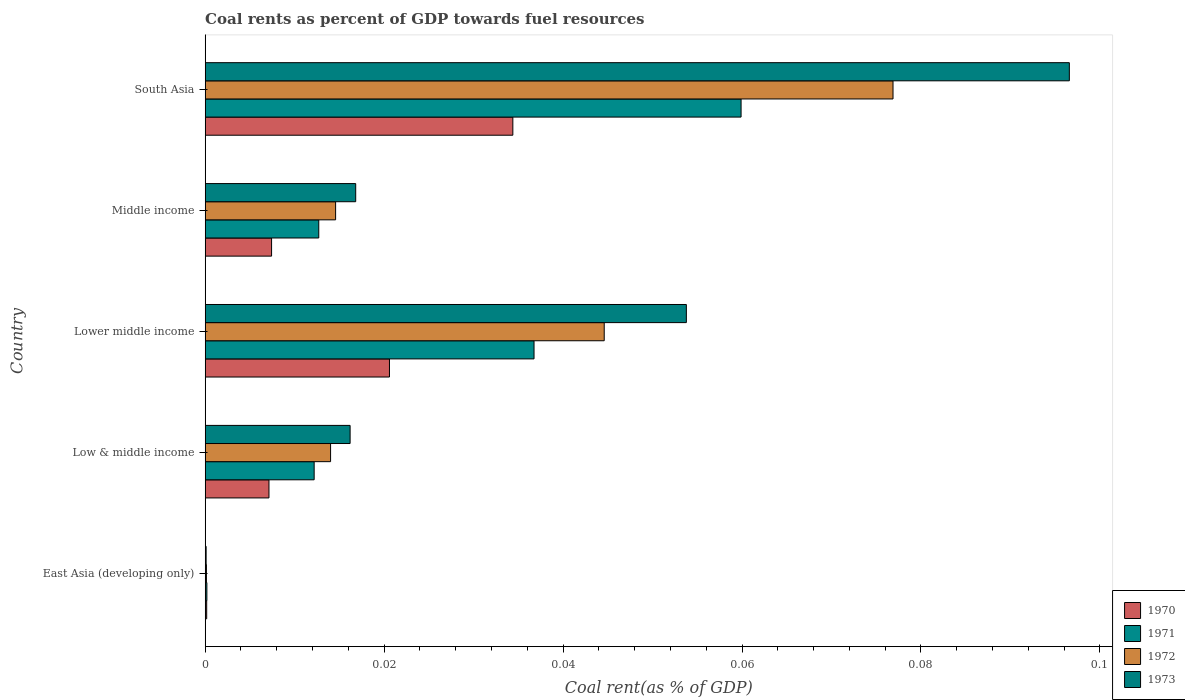Are the number of bars on each tick of the Y-axis equal?
Keep it short and to the point. Yes. How many bars are there on the 2nd tick from the top?
Offer a very short reply. 4. How many bars are there on the 3rd tick from the bottom?
Give a very brief answer. 4. What is the coal rent in 1973 in East Asia (developing only)?
Your response must be concise. 0. Across all countries, what is the maximum coal rent in 1970?
Offer a terse response. 0.03. Across all countries, what is the minimum coal rent in 1972?
Make the answer very short. 0. In which country was the coal rent in 1971 maximum?
Your answer should be compact. South Asia. In which country was the coal rent in 1972 minimum?
Keep it short and to the point. East Asia (developing only). What is the total coal rent in 1970 in the graph?
Keep it short and to the point. 0.07. What is the difference between the coal rent in 1970 in East Asia (developing only) and that in Middle income?
Your response must be concise. -0.01. What is the difference between the coal rent in 1973 in South Asia and the coal rent in 1971 in East Asia (developing only)?
Ensure brevity in your answer.  0.1. What is the average coal rent in 1971 per country?
Provide a succinct answer. 0.02. What is the difference between the coal rent in 1973 and coal rent in 1972 in Lower middle income?
Provide a succinct answer. 0.01. In how many countries, is the coal rent in 1972 greater than 0.052000000000000005 %?
Offer a terse response. 1. What is the ratio of the coal rent in 1970 in East Asia (developing only) to that in Low & middle income?
Offer a very short reply. 0.02. Is the coal rent in 1973 in East Asia (developing only) less than that in Low & middle income?
Your response must be concise. Yes. Is the difference between the coal rent in 1973 in Low & middle income and Middle income greater than the difference between the coal rent in 1972 in Low & middle income and Middle income?
Your answer should be compact. No. What is the difference between the highest and the second highest coal rent in 1970?
Provide a succinct answer. 0.01. What is the difference between the highest and the lowest coal rent in 1973?
Keep it short and to the point. 0.1. Is it the case that in every country, the sum of the coal rent in 1970 and coal rent in 1973 is greater than the sum of coal rent in 1972 and coal rent in 1971?
Your answer should be compact. No. Is it the case that in every country, the sum of the coal rent in 1973 and coal rent in 1971 is greater than the coal rent in 1972?
Your answer should be compact. Yes. How many bars are there?
Your answer should be very brief. 20. Does the graph contain any zero values?
Provide a succinct answer. No. Does the graph contain grids?
Ensure brevity in your answer.  No. How many legend labels are there?
Your response must be concise. 4. How are the legend labels stacked?
Offer a very short reply. Vertical. What is the title of the graph?
Provide a short and direct response. Coal rents as percent of GDP towards fuel resources. Does "1985" appear as one of the legend labels in the graph?
Ensure brevity in your answer.  No. What is the label or title of the X-axis?
Give a very brief answer. Coal rent(as % of GDP). What is the Coal rent(as % of GDP) in 1970 in East Asia (developing only)?
Provide a short and direct response. 0. What is the Coal rent(as % of GDP) of 1971 in East Asia (developing only)?
Make the answer very short. 0. What is the Coal rent(as % of GDP) in 1972 in East Asia (developing only)?
Your answer should be compact. 0. What is the Coal rent(as % of GDP) in 1973 in East Asia (developing only)?
Your answer should be very brief. 0. What is the Coal rent(as % of GDP) in 1970 in Low & middle income?
Offer a very short reply. 0.01. What is the Coal rent(as % of GDP) in 1971 in Low & middle income?
Ensure brevity in your answer.  0.01. What is the Coal rent(as % of GDP) of 1972 in Low & middle income?
Your response must be concise. 0.01. What is the Coal rent(as % of GDP) of 1973 in Low & middle income?
Offer a terse response. 0.02. What is the Coal rent(as % of GDP) in 1970 in Lower middle income?
Your response must be concise. 0.02. What is the Coal rent(as % of GDP) of 1971 in Lower middle income?
Provide a short and direct response. 0.04. What is the Coal rent(as % of GDP) of 1972 in Lower middle income?
Offer a very short reply. 0.04. What is the Coal rent(as % of GDP) in 1973 in Lower middle income?
Give a very brief answer. 0.05. What is the Coal rent(as % of GDP) in 1970 in Middle income?
Offer a terse response. 0.01. What is the Coal rent(as % of GDP) in 1971 in Middle income?
Provide a succinct answer. 0.01. What is the Coal rent(as % of GDP) of 1972 in Middle income?
Provide a short and direct response. 0.01. What is the Coal rent(as % of GDP) in 1973 in Middle income?
Your response must be concise. 0.02. What is the Coal rent(as % of GDP) of 1970 in South Asia?
Your response must be concise. 0.03. What is the Coal rent(as % of GDP) in 1971 in South Asia?
Your answer should be very brief. 0.06. What is the Coal rent(as % of GDP) of 1972 in South Asia?
Offer a very short reply. 0.08. What is the Coal rent(as % of GDP) of 1973 in South Asia?
Offer a very short reply. 0.1. Across all countries, what is the maximum Coal rent(as % of GDP) of 1970?
Keep it short and to the point. 0.03. Across all countries, what is the maximum Coal rent(as % of GDP) of 1971?
Your response must be concise. 0.06. Across all countries, what is the maximum Coal rent(as % of GDP) of 1972?
Your answer should be very brief. 0.08. Across all countries, what is the maximum Coal rent(as % of GDP) in 1973?
Make the answer very short. 0.1. Across all countries, what is the minimum Coal rent(as % of GDP) in 1970?
Give a very brief answer. 0. Across all countries, what is the minimum Coal rent(as % of GDP) of 1971?
Keep it short and to the point. 0. Across all countries, what is the minimum Coal rent(as % of GDP) in 1972?
Give a very brief answer. 0. Across all countries, what is the minimum Coal rent(as % of GDP) in 1973?
Your response must be concise. 0. What is the total Coal rent(as % of GDP) in 1970 in the graph?
Your answer should be compact. 0.07. What is the total Coal rent(as % of GDP) of 1971 in the graph?
Provide a succinct answer. 0.12. What is the total Coal rent(as % of GDP) of 1972 in the graph?
Make the answer very short. 0.15. What is the total Coal rent(as % of GDP) of 1973 in the graph?
Your answer should be compact. 0.18. What is the difference between the Coal rent(as % of GDP) of 1970 in East Asia (developing only) and that in Low & middle income?
Give a very brief answer. -0.01. What is the difference between the Coal rent(as % of GDP) in 1971 in East Asia (developing only) and that in Low & middle income?
Offer a terse response. -0.01. What is the difference between the Coal rent(as % of GDP) of 1972 in East Asia (developing only) and that in Low & middle income?
Offer a terse response. -0.01. What is the difference between the Coal rent(as % of GDP) of 1973 in East Asia (developing only) and that in Low & middle income?
Provide a succinct answer. -0.02. What is the difference between the Coal rent(as % of GDP) of 1970 in East Asia (developing only) and that in Lower middle income?
Provide a short and direct response. -0.02. What is the difference between the Coal rent(as % of GDP) of 1971 in East Asia (developing only) and that in Lower middle income?
Offer a terse response. -0.04. What is the difference between the Coal rent(as % of GDP) of 1972 in East Asia (developing only) and that in Lower middle income?
Your answer should be compact. -0.04. What is the difference between the Coal rent(as % of GDP) of 1973 in East Asia (developing only) and that in Lower middle income?
Offer a terse response. -0.05. What is the difference between the Coal rent(as % of GDP) of 1970 in East Asia (developing only) and that in Middle income?
Your response must be concise. -0.01. What is the difference between the Coal rent(as % of GDP) of 1971 in East Asia (developing only) and that in Middle income?
Ensure brevity in your answer.  -0.01. What is the difference between the Coal rent(as % of GDP) of 1972 in East Asia (developing only) and that in Middle income?
Your answer should be compact. -0.01. What is the difference between the Coal rent(as % of GDP) in 1973 in East Asia (developing only) and that in Middle income?
Give a very brief answer. -0.02. What is the difference between the Coal rent(as % of GDP) of 1970 in East Asia (developing only) and that in South Asia?
Your response must be concise. -0.03. What is the difference between the Coal rent(as % of GDP) in 1971 in East Asia (developing only) and that in South Asia?
Ensure brevity in your answer.  -0.06. What is the difference between the Coal rent(as % of GDP) in 1972 in East Asia (developing only) and that in South Asia?
Make the answer very short. -0.08. What is the difference between the Coal rent(as % of GDP) of 1973 in East Asia (developing only) and that in South Asia?
Offer a terse response. -0.1. What is the difference between the Coal rent(as % of GDP) in 1970 in Low & middle income and that in Lower middle income?
Your answer should be very brief. -0.01. What is the difference between the Coal rent(as % of GDP) in 1971 in Low & middle income and that in Lower middle income?
Your response must be concise. -0.02. What is the difference between the Coal rent(as % of GDP) of 1972 in Low & middle income and that in Lower middle income?
Your answer should be very brief. -0.03. What is the difference between the Coal rent(as % of GDP) of 1973 in Low & middle income and that in Lower middle income?
Provide a succinct answer. -0.04. What is the difference between the Coal rent(as % of GDP) in 1970 in Low & middle income and that in Middle income?
Ensure brevity in your answer.  -0. What is the difference between the Coal rent(as % of GDP) of 1971 in Low & middle income and that in Middle income?
Offer a terse response. -0. What is the difference between the Coal rent(as % of GDP) in 1972 in Low & middle income and that in Middle income?
Offer a terse response. -0. What is the difference between the Coal rent(as % of GDP) of 1973 in Low & middle income and that in Middle income?
Your response must be concise. -0. What is the difference between the Coal rent(as % of GDP) in 1970 in Low & middle income and that in South Asia?
Your response must be concise. -0.03. What is the difference between the Coal rent(as % of GDP) of 1971 in Low & middle income and that in South Asia?
Offer a terse response. -0.05. What is the difference between the Coal rent(as % of GDP) of 1972 in Low & middle income and that in South Asia?
Provide a short and direct response. -0.06. What is the difference between the Coal rent(as % of GDP) of 1973 in Low & middle income and that in South Asia?
Your response must be concise. -0.08. What is the difference between the Coal rent(as % of GDP) in 1970 in Lower middle income and that in Middle income?
Your response must be concise. 0.01. What is the difference between the Coal rent(as % of GDP) in 1971 in Lower middle income and that in Middle income?
Offer a terse response. 0.02. What is the difference between the Coal rent(as % of GDP) of 1973 in Lower middle income and that in Middle income?
Ensure brevity in your answer.  0.04. What is the difference between the Coal rent(as % of GDP) of 1970 in Lower middle income and that in South Asia?
Your response must be concise. -0.01. What is the difference between the Coal rent(as % of GDP) in 1971 in Lower middle income and that in South Asia?
Keep it short and to the point. -0.02. What is the difference between the Coal rent(as % of GDP) in 1972 in Lower middle income and that in South Asia?
Your answer should be compact. -0.03. What is the difference between the Coal rent(as % of GDP) in 1973 in Lower middle income and that in South Asia?
Offer a very short reply. -0.04. What is the difference between the Coal rent(as % of GDP) of 1970 in Middle income and that in South Asia?
Make the answer very short. -0.03. What is the difference between the Coal rent(as % of GDP) in 1971 in Middle income and that in South Asia?
Ensure brevity in your answer.  -0.05. What is the difference between the Coal rent(as % of GDP) in 1972 in Middle income and that in South Asia?
Your response must be concise. -0.06. What is the difference between the Coal rent(as % of GDP) of 1973 in Middle income and that in South Asia?
Provide a short and direct response. -0.08. What is the difference between the Coal rent(as % of GDP) in 1970 in East Asia (developing only) and the Coal rent(as % of GDP) in 1971 in Low & middle income?
Provide a succinct answer. -0.01. What is the difference between the Coal rent(as % of GDP) in 1970 in East Asia (developing only) and the Coal rent(as % of GDP) in 1972 in Low & middle income?
Your response must be concise. -0.01. What is the difference between the Coal rent(as % of GDP) of 1970 in East Asia (developing only) and the Coal rent(as % of GDP) of 1973 in Low & middle income?
Your answer should be compact. -0.02. What is the difference between the Coal rent(as % of GDP) of 1971 in East Asia (developing only) and the Coal rent(as % of GDP) of 1972 in Low & middle income?
Offer a very short reply. -0.01. What is the difference between the Coal rent(as % of GDP) in 1971 in East Asia (developing only) and the Coal rent(as % of GDP) in 1973 in Low & middle income?
Keep it short and to the point. -0.02. What is the difference between the Coal rent(as % of GDP) of 1972 in East Asia (developing only) and the Coal rent(as % of GDP) of 1973 in Low & middle income?
Your response must be concise. -0.02. What is the difference between the Coal rent(as % of GDP) in 1970 in East Asia (developing only) and the Coal rent(as % of GDP) in 1971 in Lower middle income?
Offer a very short reply. -0.04. What is the difference between the Coal rent(as % of GDP) of 1970 in East Asia (developing only) and the Coal rent(as % of GDP) of 1972 in Lower middle income?
Offer a very short reply. -0.04. What is the difference between the Coal rent(as % of GDP) in 1970 in East Asia (developing only) and the Coal rent(as % of GDP) in 1973 in Lower middle income?
Your response must be concise. -0.05. What is the difference between the Coal rent(as % of GDP) in 1971 in East Asia (developing only) and the Coal rent(as % of GDP) in 1972 in Lower middle income?
Ensure brevity in your answer.  -0.04. What is the difference between the Coal rent(as % of GDP) in 1971 in East Asia (developing only) and the Coal rent(as % of GDP) in 1973 in Lower middle income?
Keep it short and to the point. -0.05. What is the difference between the Coal rent(as % of GDP) in 1972 in East Asia (developing only) and the Coal rent(as % of GDP) in 1973 in Lower middle income?
Your answer should be very brief. -0.05. What is the difference between the Coal rent(as % of GDP) of 1970 in East Asia (developing only) and the Coal rent(as % of GDP) of 1971 in Middle income?
Keep it short and to the point. -0.01. What is the difference between the Coal rent(as % of GDP) in 1970 in East Asia (developing only) and the Coal rent(as % of GDP) in 1972 in Middle income?
Keep it short and to the point. -0.01. What is the difference between the Coal rent(as % of GDP) of 1970 in East Asia (developing only) and the Coal rent(as % of GDP) of 1973 in Middle income?
Keep it short and to the point. -0.02. What is the difference between the Coal rent(as % of GDP) in 1971 in East Asia (developing only) and the Coal rent(as % of GDP) in 1972 in Middle income?
Your response must be concise. -0.01. What is the difference between the Coal rent(as % of GDP) of 1971 in East Asia (developing only) and the Coal rent(as % of GDP) of 1973 in Middle income?
Give a very brief answer. -0.02. What is the difference between the Coal rent(as % of GDP) in 1972 in East Asia (developing only) and the Coal rent(as % of GDP) in 1973 in Middle income?
Give a very brief answer. -0.02. What is the difference between the Coal rent(as % of GDP) of 1970 in East Asia (developing only) and the Coal rent(as % of GDP) of 1971 in South Asia?
Give a very brief answer. -0.06. What is the difference between the Coal rent(as % of GDP) of 1970 in East Asia (developing only) and the Coal rent(as % of GDP) of 1972 in South Asia?
Make the answer very short. -0.08. What is the difference between the Coal rent(as % of GDP) of 1970 in East Asia (developing only) and the Coal rent(as % of GDP) of 1973 in South Asia?
Provide a short and direct response. -0.1. What is the difference between the Coal rent(as % of GDP) in 1971 in East Asia (developing only) and the Coal rent(as % of GDP) in 1972 in South Asia?
Make the answer very short. -0.08. What is the difference between the Coal rent(as % of GDP) of 1971 in East Asia (developing only) and the Coal rent(as % of GDP) of 1973 in South Asia?
Make the answer very short. -0.1. What is the difference between the Coal rent(as % of GDP) in 1972 in East Asia (developing only) and the Coal rent(as % of GDP) in 1973 in South Asia?
Offer a very short reply. -0.1. What is the difference between the Coal rent(as % of GDP) in 1970 in Low & middle income and the Coal rent(as % of GDP) in 1971 in Lower middle income?
Provide a short and direct response. -0.03. What is the difference between the Coal rent(as % of GDP) of 1970 in Low & middle income and the Coal rent(as % of GDP) of 1972 in Lower middle income?
Offer a very short reply. -0.04. What is the difference between the Coal rent(as % of GDP) of 1970 in Low & middle income and the Coal rent(as % of GDP) of 1973 in Lower middle income?
Offer a terse response. -0.05. What is the difference between the Coal rent(as % of GDP) in 1971 in Low & middle income and the Coal rent(as % of GDP) in 1972 in Lower middle income?
Your answer should be very brief. -0.03. What is the difference between the Coal rent(as % of GDP) in 1971 in Low & middle income and the Coal rent(as % of GDP) in 1973 in Lower middle income?
Your response must be concise. -0.04. What is the difference between the Coal rent(as % of GDP) of 1972 in Low & middle income and the Coal rent(as % of GDP) of 1973 in Lower middle income?
Keep it short and to the point. -0.04. What is the difference between the Coal rent(as % of GDP) in 1970 in Low & middle income and the Coal rent(as % of GDP) in 1971 in Middle income?
Keep it short and to the point. -0.01. What is the difference between the Coal rent(as % of GDP) in 1970 in Low & middle income and the Coal rent(as % of GDP) in 1972 in Middle income?
Your answer should be very brief. -0.01. What is the difference between the Coal rent(as % of GDP) of 1970 in Low & middle income and the Coal rent(as % of GDP) of 1973 in Middle income?
Offer a terse response. -0.01. What is the difference between the Coal rent(as % of GDP) of 1971 in Low & middle income and the Coal rent(as % of GDP) of 1972 in Middle income?
Offer a very short reply. -0. What is the difference between the Coal rent(as % of GDP) in 1971 in Low & middle income and the Coal rent(as % of GDP) in 1973 in Middle income?
Provide a short and direct response. -0. What is the difference between the Coal rent(as % of GDP) of 1972 in Low & middle income and the Coal rent(as % of GDP) of 1973 in Middle income?
Offer a terse response. -0. What is the difference between the Coal rent(as % of GDP) in 1970 in Low & middle income and the Coal rent(as % of GDP) in 1971 in South Asia?
Keep it short and to the point. -0.05. What is the difference between the Coal rent(as % of GDP) in 1970 in Low & middle income and the Coal rent(as % of GDP) in 1972 in South Asia?
Offer a terse response. -0.07. What is the difference between the Coal rent(as % of GDP) of 1970 in Low & middle income and the Coal rent(as % of GDP) of 1973 in South Asia?
Offer a terse response. -0.09. What is the difference between the Coal rent(as % of GDP) in 1971 in Low & middle income and the Coal rent(as % of GDP) in 1972 in South Asia?
Provide a succinct answer. -0.06. What is the difference between the Coal rent(as % of GDP) in 1971 in Low & middle income and the Coal rent(as % of GDP) in 1973 in South Asia?
Provide a succinct answer. -0.08. What is the difference between the Coal rent(as % of GDP) in 1972 in Low & middle income and the Coal rent(as % of GDP) in 1973 in South Asia?
Provide a succinct answer. -0.08. What is the difference between the Coal rent(as % of GDP) of 1970 in Lower middle income and the Coal rent(as % of GDP) of 1971 in Middle income?
Give a very brief answer. 0.01. What is the difference between the Coal rent(as % of GDP) of 1970 in Lower middle income and the Coal rent(as % of GDP) of 1972 in Middle income?
Your answer should be very brief. 0.01. What is the difference between the Coal rent(as % of GDP) in 1970 in Lower middle income and the Coal rent(as % of GDP) in 1973 in Middle income?
Your response must be concise. 0. What is the difference between the Coal rent(as % of GDP) in 1971 in Lower middle income and the Coal rent(as % of GDP) in 1972 in Middle income?
Make the answer very short. 0.02. What is the difference between the Coal rent(as % of GDP) of 1971 in Lower middle income and the Coal rent(as % of GDP) of 1973 in Middle income?
Provide a short and direct response. 0.02. What is the difference between the Coal rent(as % of GDP) in 1972 in Lower middle income and the Coal rent(as % of GDP) in 1973 in Middle income?
Ensure brevity in your answer.  0.03. What is the difference between the Coal rent(as % of GDP) of 1970 in Lower middle income and the Coal rent(as % of GDP) of 1971 in South Asia?
Keep it short and to the point. -0.04. What is the difference between the Coal rent(as % of GDP) of 1970 in Lower middle income and the Coal rent(as % of GDP) of 1972 in South Asia?
Your response must be concise. -0.06. What is the difference between the Coal rent(as % of GDP) in 1970 in Lower middle income and the Coal rent(as % of GDP) in 1973 in South Asia?
Your response must be concise. -0.08. What is the difference between the Coal rent(as % of GDP) of 1971 in Lower middle income and the Coal rent(as % of GDP) of 1972 in South Asia?
Provide a short and direct response. -0.04. What is the difference between the Coal rent(as % of GDP) in 1971 in Lower middle income and the Coal rent(as % of GDP) in 1973 in South Asia?
Your response must be concise. -0.06. What is the difference between the Coal rent(as % of GDP) of 1972 in Lower middle income and the Coal rent(as % of GDP) of 1973 in South Asia?
Provide a succinct answer. -0.05. What is the difference between the Coal rent(as % of GDP) in 1970 in Middle income and the Coal rent(as % of GDP) in 1971 in South Asia?
Give a very brief answer. -0.05. What is the difference between the Coal rent(as % of GDP) of 1970 in Middle income and the Coal rent(as % of GDP) of 1972 in South Asia?
Provide a succinct answer. -0.07. What is the difference between the Coal rent(as % of GDP) of 1970 in Middle income and the Coal rent(as % of GDP) of 1973 in South Asia?
Keep it short and to the point. -0.09. What is the difference between the Coal rent(as % of GDP) in 1971 in Middle income and the Coal rent(as % of GDP) in 1972 in South Asia?
Keep it short and to the point. -0.06. What is the difference between the Coal rent(as % of GDP) in 1971 in Middle income and the Coal rent(as % of GDP) in 1973 in South Asia?
Make the answer very short. -0.08. What is the difference between the Coal rent(as % of GDP) in 1972 in Middle income and the Coal rent(as % of GDP) in 1973 in South Asia?
Offer a very short reply. -0.08. What is the average Coal rent(as % of GDP) of 1970 per country?
Your answer should be very brief. 0.01. What is the average Coal rent(as % of GDP) in 1971 per country?
Provide a short and direct response. 0.02. What is the average Coal rent(as % of GDP) in 1972 per country?
Provide a short and direct response. 0.03. What is the average Coal rent(as % of GDP) of 1973 per country?
Your answer should be very brief. 0.04. What is the difference between the Coal rent(as % of GDP) of 1970 and Coal rent(as % of GDP) of 1972 in East Asia (developing only)?
Provide a succinct answer. 0. What is the difference between the Coal rent(as % of GDP) of 1970 and Coal rent(as % of GDP) of 1971 in Low & middle income?
Your response must be concise. -0.01. What is the difference between the Coal rent(as % of GDP) of 1970 and Coal rent(as % of GDP) of 1972 in Low & middle income?
Provide a succinct answer. -0.01. What is the difference between the Coal rent(as % of GDP) of 1970 and Coal rent(as % of GDP) of 1973 in Low & middle income?
Provide a succinct answer. -0.01. What is the difference between the Coal rent(as % of GDP) in 1971 and Coal rent(as % of GDP) in 1972 in Low & middle income?
Your answer should be compact. -0. What is the difference between the Coal rent(as % of GDP) of 1971 and Coal rent(as % of GDP) of 1973 in Low & middle income?
Your response must be concise. -0. What is the difference between the Coal rent(as % of GDP) in 1972 and Coal rent(as % of GDP) in 1973 in Low & middle income?
Your answer should be compact. -0. What is the difference between the Coal rent(as % of GDP) of 1970 and Coal rent(as % of GDP) of 1971 in Lower middle income?
Offer a very short reply. -0.02. What is the difference between the Coal rent(as % of GDP) in 1970 and Coal rent(as % of GDP) in 1972 in Lower middle income?
Your answer should be compact. -0.02. What is the difference between the Coal rent(as % of GDP) in 1970 and Coal rent(as % of GDP) in 1973 in Lower middle income?
Your response must be concise. -0.03. What is the difference between the Coal rent(as % of GDP) in 1971 and Coal rent(as % of GDP) in 1972 in Lower middle income?
Offer a terse response. -0.01. What is the difference between the Coal rent(as % of GDP) in 1971 and Coal rent(as % of GDP) in 1973 in Lower middle income?
Offer a terse response. -0.02. What is the difference between the Coal rent(as % of GDP) of 1972 and Coal rent(as % of GDP) of 1973 in Lower middle income?
Your response must be concise. -0.01. What is the difference between the Coal rent(as % of GDP) in 1970 and Coal rent(as % of GDP) in 1971 in Middle income?
Your answer should be very brief. -0.01. What is the difference between the Coal rent(as % of GDP) in 1970 and Coal rent(as % of GDP) in 1972 in Middle income?
Your answer should be very brief. -0.01. What is the difference between the Coal rent(as % of GDP) of 1970 and Coal rent(as % of GDP) of 1973 in Middle income?
Give a very brief answer. -0.01. What is the difference between the Coal rent(as % of GDP) in 1971 and Coal rent(as % of GDP) in 1972 in Middle income?
Provide a succinct answer. -0. What is the difference between the Coal rent(as % of GDP) in 1971 and Coal rent(as % of GDP) in 1973 in Middle income?
Provide a succinct answer. -0. What is the difference between the Coal rent(as % of GDP) of 1972 and Coal rent(as % of GDP) of 1973 in Middle income?
Your answer should be very brief. -0. What is the difference between the Coal rent(as % of GDP) in 1970 and Coal rent(as % of GDP) in 1971 in South Asia?
Give a very brief answer. -0.03. What is the difference between the Coal rent(as % of GDP) of 1970 and Coal rent(as % of GDP) of 1972 in South Asia?
Offer a very short reply. -0.04. What is the difference between the Coal rent(as % of GDP) in 1970 and Coal rent(as % of GDP) in 1973 in South Asia?
Offer a very short reply. -0.06. What is the difference between the Coal rent(as % of GDP) of 1971 and Coal rent(as % of GDP) of 1972 in South Asia?
Provide a succinct answer. -0.02. What is the difference between the Coal rent(as % of GDP) of 1971 and Coal rent(as % of GDP) of 1973 in South Asia?
Give a very brief answer. -0.04. What is the difference between the Coal rent(as % of GDP) in 1972 and Coal rent(as % of GDP) in 1973 in South Asia?
Ensure brevity in your answer.  -0.02. What is the ratio of the Coal rent(as % of GDP) in 1970 in East Asia (developing only) to that in Low & middle income?
Provide a succinct answer. 0.02. What is the ratio of the Coal rent(as % of GDP) of 1971 in East Asia (developing only) to that in Low & middle income?
Your answer should be compact. 0.02. What is the ratio of the Coal rent(as % of GDP) in 1972 in East Asia (developing only) to that in Low & middle income?
Give a very brief answer. 0.01. What is the ratio of the Coal rent(as % of GDP) in 1973 in East Asia (developing only) to that in Low & middle income?
Ensure brevity in your answer.  0.01. What is the ratio of the Coal rent(as % of GDP) in 1970 in East Asia (developing only) to that in Lower middle income?
Offer a very short reply. 0.01. What is the ratio of the Coal rent(as % of GDP) in 1971 in East Asia (developing only) to that in Lower middle income?
Make the answer very short. 0.01. What is the ratio of the Coal rent(as % of GDP) in 1972 in East Asia (developing only) to that in Lower middle income?
Ensure brevity in your answer.  0. What is the ratio of the Coal rent(as % of GDP) in 1973 in East Asia (developing only) to that in Lower middle income?
Your answer should be compact. 0. What is the ratio of the Coal rent(as % of GDP) of 1970 in East Asia (developing only) to that in Middle income?
Offer a terse response. 0.02. What is the ratio of the Coal rent(as % of GDP) of 1971 in East Asia (developing only) to that in Middle income?
Keep it short and to the point. 0.01. What is the ratio of the Coal rent(as % of GDP) of 1972 in East Asia (developing only) to that in Middle income?
Make the answer very short. 0.01. What is the ratio of the Coal rent(as % of GDP) in 1973 in East Asia (developing only) to that in Middle income?
Your answer should be very brief. 0.01. What is the ratio of the Coal rent(as % of GDP) in 1970 in East Asia (developing only) to that in South Asia?
Your answer should be very brief. 0. What is the ratio of the Coal rent(as % of GDP) of 1971 in East Asia (developing only) to that in South Asia?
Your response must be concise. 0. What is the ratio of the Coal rent(as % of GDP) in 1972 in East Asia (developing only) to that in South Asia?
Offer a terse response. 0. What is the ratio of the Coal rent(as % of GDP) in 1973 in East Asia (developing only) to that in South Asia?
Your response must be concise. 0. What is the ratio of the Coal rent(as % of GDP) in 1970 in Low & middle income to that in Lower middle income?
Provide a succinct answer. 0.35. What is the ratio of the Coal rent(as % of GDP) in 1971 in Low & middle income to that in Lower middle income?
Provide a succinct answer. 0.33. What is the ratio of the Coal rent(as % of GDP) in 1972 in Low & middle income to that in Lower middle income?
Offer a very short reply. 0.31. What is the ratio of the Coal rent(as % of GDP) in 1973 in Low & middle income to that in Lower middle income?
Make the answer very short. 0.3. What is the ratio of the Coal rent(as % of GDP) in 1970 in Low & middle income to that in Middle income?
Make the answer very short. 0.96. What is the ratio of the Coal rent(as % of GDP) of 1971 in Low & middle income to that in Middle income?
Offer a terse response. 0.96. What is the ratio of the Coal rent(as % of GDP) in 1972 in Low & middle income to that in Middle income?
Your answer should be compact. 0.96. What is the ratio of the Coal rent(as % of GDP) of 1973 in Low & middle income to that in Middle income?
Make the answer very short. 0.96. What is the ratio of the Coal rent(as % of GDP) in 1970 in Low & middle income to that in South Asia?
Offer a very short reply. 0.21. What is the ratio of the Coal rent(as % of GDP) in 1971 in Low & middle income to that in South Asia?
Provide a short and direct response. 0.2. What is the ratio of the Coal rent(as % of GDP) in 1972 in Low & middle income to that in South Asia?
Your answer should be compact. 0.18. What is the ratio of the Coal rent(as % of GDP) of 1973 in Low & middle income to that in South Asia?
Your answer should be very brief. 0.17. What is the ratio of the Coal rent(as % of GDP) of 1970 in Lower middle income to that in Middle income?
Make the answer very short. 2.78. What is the ratio of the Coal rent(as % of GDP) of 1971 in Lower middle income to that in Middle income?
Your response must be concise. 2.9. What is the ratio of the Coal rent(as % of GDP) in 1972 in Lower middle income to that in Middle income?
Your answer should be compact. 3.06. What is the ratio of the Coal rent(as % of GDP) in 1973 in Lower middle income to that in Middle income?
Ensure brevity in your answer.  3.2. What is the ratio of the Coal rent(as % of GDP) in 1970 in Lower middle income to that in South Asia?
Offer a very short reply. 0.6. What is the ratio of the Coal rent(as % of GDP) in 1971 in Lower middle income to that in South Asia?
Provide a succinct answer. 0.61. What is the ratio of the Coal rent(as % of GDP) of 1972 in Lower middle income to that in South Asia?
Your answer should be very brief. 0.58. What is the ratio of the Coal rent(as % of GDP) in 1973 in Lower middle income to that in South Asia?
Your response must be concise. 0.56. What is the ratio of the Coal rent(as % of GDP) of 1970 in Middle income to that in South Asia?
Give a very brief answer. 0.22. What is the ratio of the Coal rent(as % of GDP) of 1971 in Middle income to that in South Asia?
Your response must be concise. 0.21. What is the ratio of the Coal rent(as % of GDP) of 1972 in Middle income to that in South Asia?
Provide a succinct answer. 0.19. What is the ratio of the Coal rent(as % of GDP) of 1973 in Middle income to that in South Asia?
Provide a succinct answer. 0.17. What is the difference between the highest and the second highest Coal rent(as % of GDP) in 1970?
Your answer should be very brief. 0.01. What is the difference between the highest and the second highest Coal rent(as % of GDP) in 1971?
Offer a terse response. 0.02. What is the difference between the highest and the second highest Coal rent(as % of GDP) in 1972?
Your answer should be very brief. 0.03. What is the difference between the highest and the second highest Coal rent(as % of GDP) of 1973?
Provide a short and direct response. 0.04. What is the difference between the highest and the lowest Coal rent(as % of GDP) of 1970?
Provide a succinct answer. 0.03. What is the difference between the highest and the lowest Coal rent(as % of GDP) in 1971?
Your answer should be very brief. 0.06. What is the difference between the highest and the lowest Coal rent(as % of GDP) in 1972?
Keep it short and to the point. 0.08. What is the difference between the highest and the lowest Coal rent(as % of GDP) of 1973?
Provide a short and direct response. 0.1. 